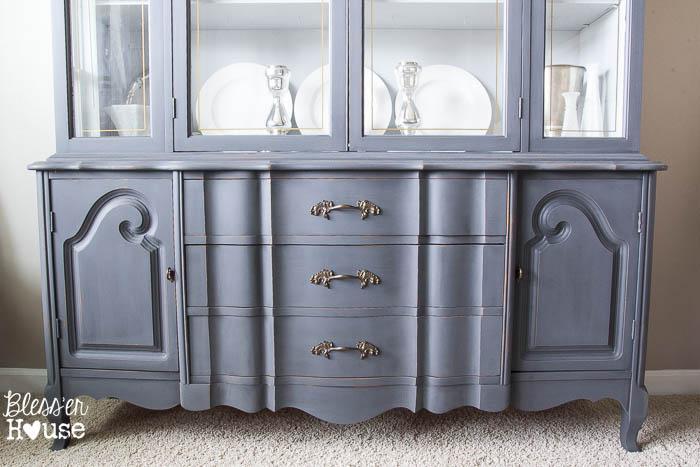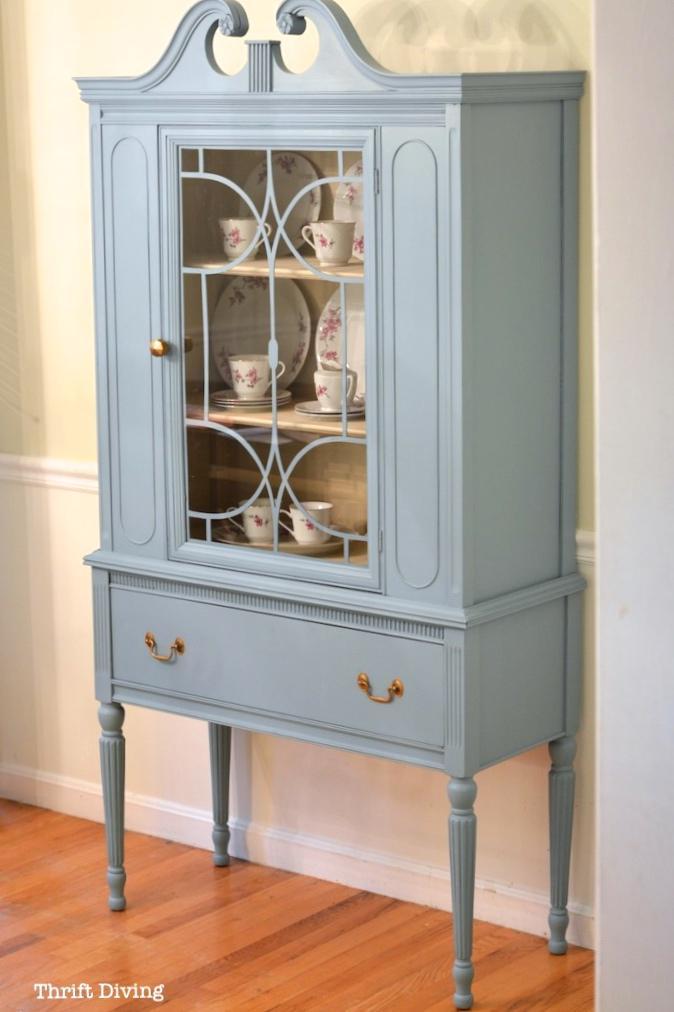The first image is the image on the left, the second image is the image on the right. Examine the images to the left and right. Is the description "The cabinet in the right image has narrow legs and decorative curved top feature." accurate? Answer yes or no. Yes. The first image is the image on the left, the second image is the image on the right. Examine the images to the left and right. Is the description "An antique wooden piece in one image has a curved top, at least one glass door with an ornate window pane design, and sits on long thin legs." accurate? Answer yes or no. Yes. The first image is the image on the left, the second image is the image on the right. Assess this claim about the two images: "The right image contains a blue china cabinet.". Correct or not? Answer yes or no. Yes. 